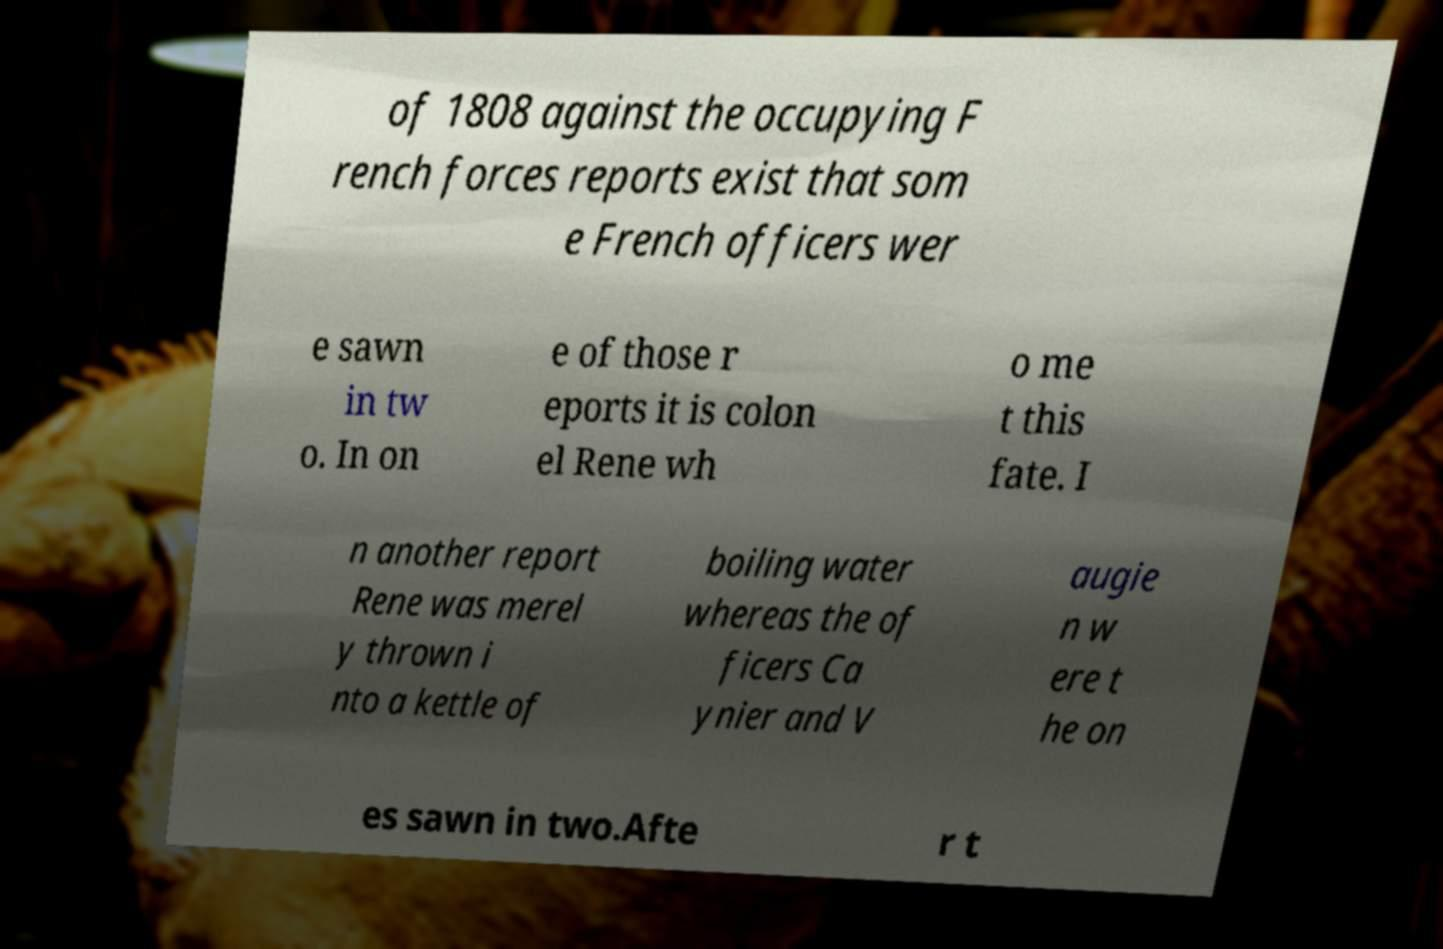Please read and relay the text visible in this image. What does it say? of 1808 against the occupying F rench forces reports exist that som e French officers wer e sawn in tw o. In on e of those r eports it is colon el Rene wh o me t this fate. I n another report Rene was merel y thrown i nto a kettle of boiling water whereas the of ficers Ca ynier and V augie n w ere t he on es sawn in two.Afte r t 